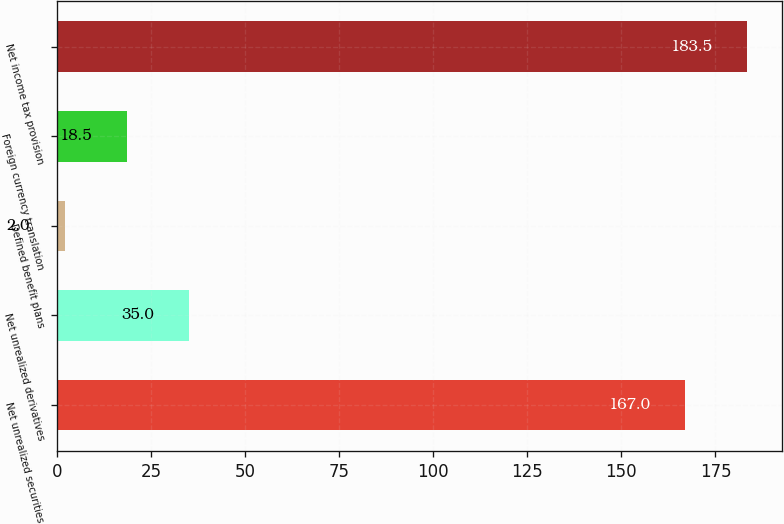<chart> <loc_0><loc_0><loc_500><loc_500><bar_chart><fcel>Net unrealized securities<fcel>Net unrealized derivatives<fcel>Defined benefit plans<fcel>Foreign currency translation<fcel>Net income tax provision<nl><fcel>167<fcel>35<fcel>2<fcel>18.5<fcel>183.5<nl></chart> 